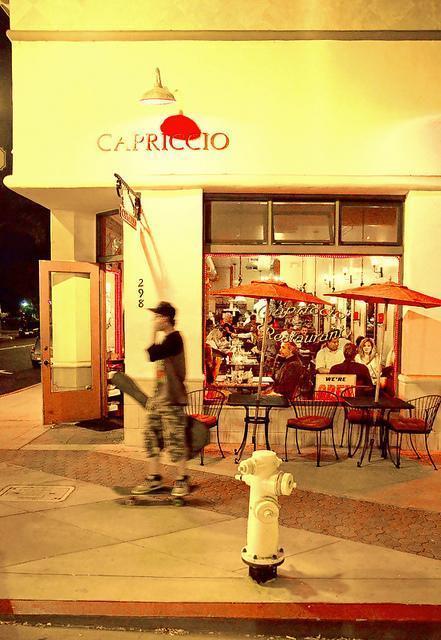How many umbrellas are there?
Give a very brief answer. 2. 